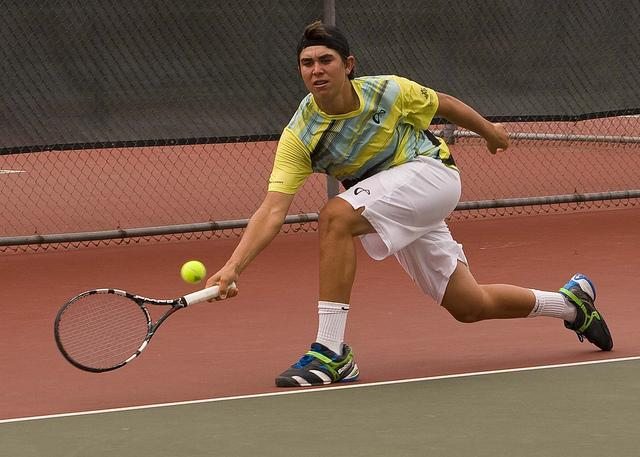What shot is he using to hit the ball? Please explain your reasoning. forehand. He's holding the racket in a forehand position and he's just about to hit the ball, so it's obvious that a forehand is what he'll be hitting the ball with. 